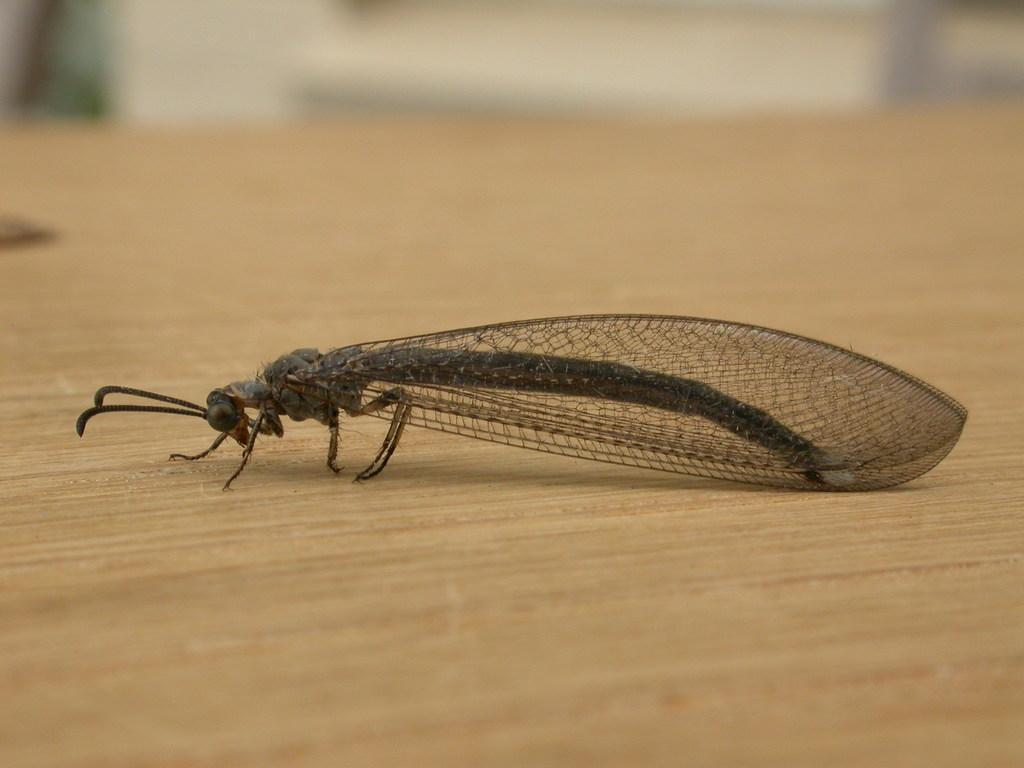How would you summarize this image in a sentence or two? In the middle of this image, there is an insect having wings and legs, on a wooden surface. And the background is blurred. 